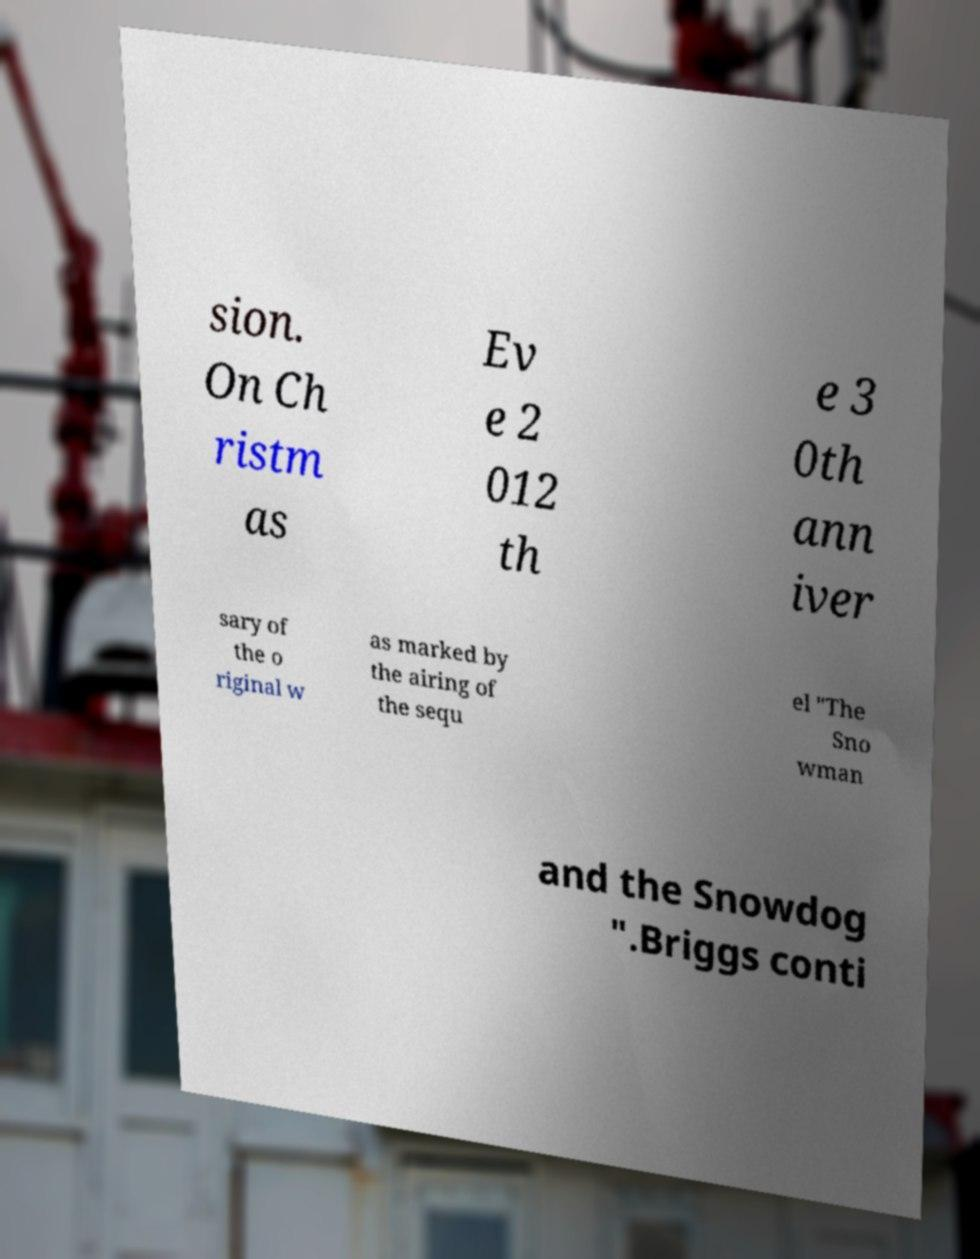Could you extract and type out the text from this image? sion. On Ch ristm as Ev e 2 012 th e 3 0th ann iver sary of the o riginal w as marked by the airing of the sequ el "The Sno wman and the Snowdog ".Briggs conti 